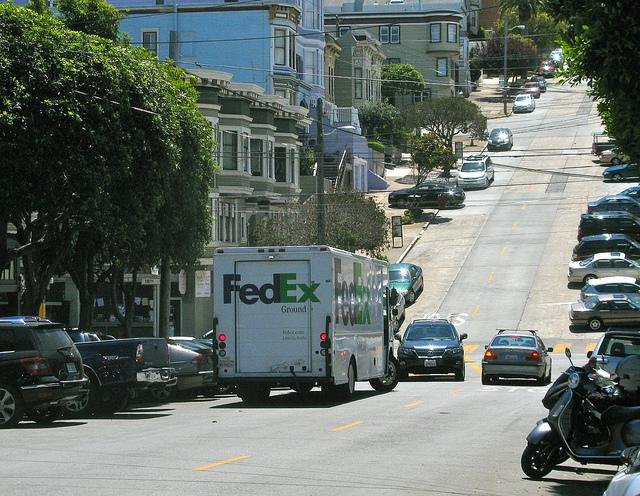Which car is in greatest danger if the FedEx car rushed forward? Please explain your reasoning. blue suv. The blue car is closest to the fedex truck. 